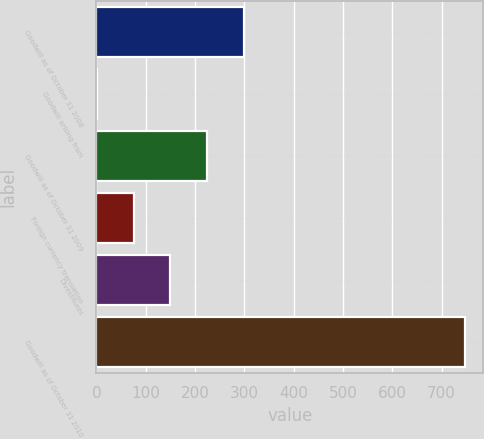Convert chart to OTSL. <chart><loc_0><loc_0><loc_500><loc_500><bar_chart><fcel>Goodwill as of October 31 2008<fcel>Goodwill arising from<fcel>Goodwill as of October 31 2009<fcel>Foreign currency translation<fcel>Divestitures<fcel>Goodwill as of October 31 2010<nl><fcel>299.4<fcel>1<fcel>224.8<fcel>75.6<fcel>150.2<fcel>747<nl></chart> 